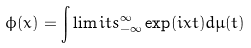Convert formula to latex. <formula><loc_0><loc_0><loc_500><loc_500>\phi ( x ) = \int \lim i t s _ { - \infty } ^ { \infty } \exp ( i x t ) d \mu ( t )</formula> 